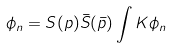Convert formula to latex. <formula><loc_0><loc_0><loc_500><loc_500>\phi _ { n } = S ( p ) \bar { S } ( \bar { p } ) \int K \phi _ { n }</formula> 